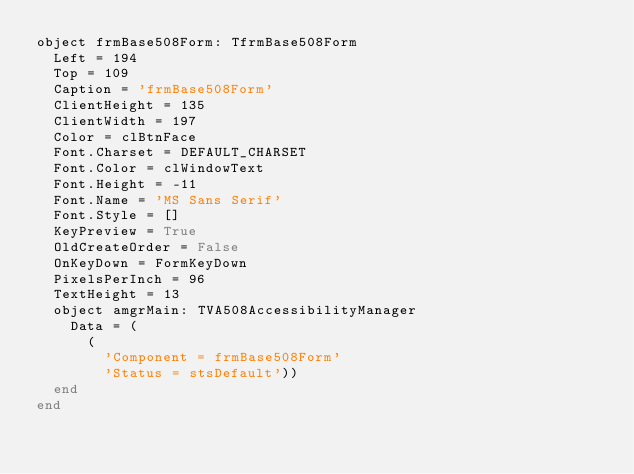<code> <loc_0><loc_0><loc_500><loc_500><_Pascal_>object frmBase508Form: TfrmBase508Form
  Left = 194
  Top = 109
  Caption = 'frmBase508Form'
  ClientHeight = 135
  ClientWidth = 197
  Color = clBtnFace
  Font.Charset = DEFAULT_CHARSET
  Font.Color = clWindowText
  Font.Height = -11
  Font.Name = 'MS Sans Serif'
  Font.Style = []
  KeyPreview = True
  OldCreateOrder = False
  OnKeyDown = FormKeyDown
  PixelsPerInch = 96
  TextHeight = 13
  object amgrMain: TVA508AccessibilityManager
    Data = (
      (
        'Component = frmBase508Form'
        'Status = stsDefault'))
  end
end
</code> 